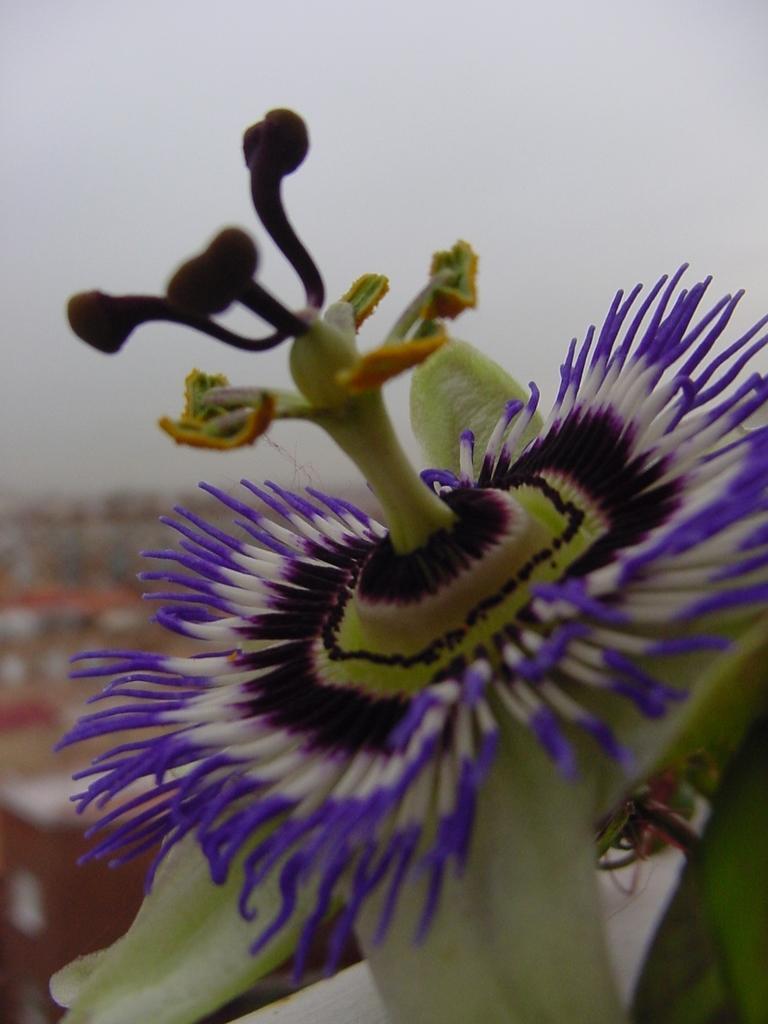Could you give a brief overview of what you see in this image? In this image we can see a flower. 